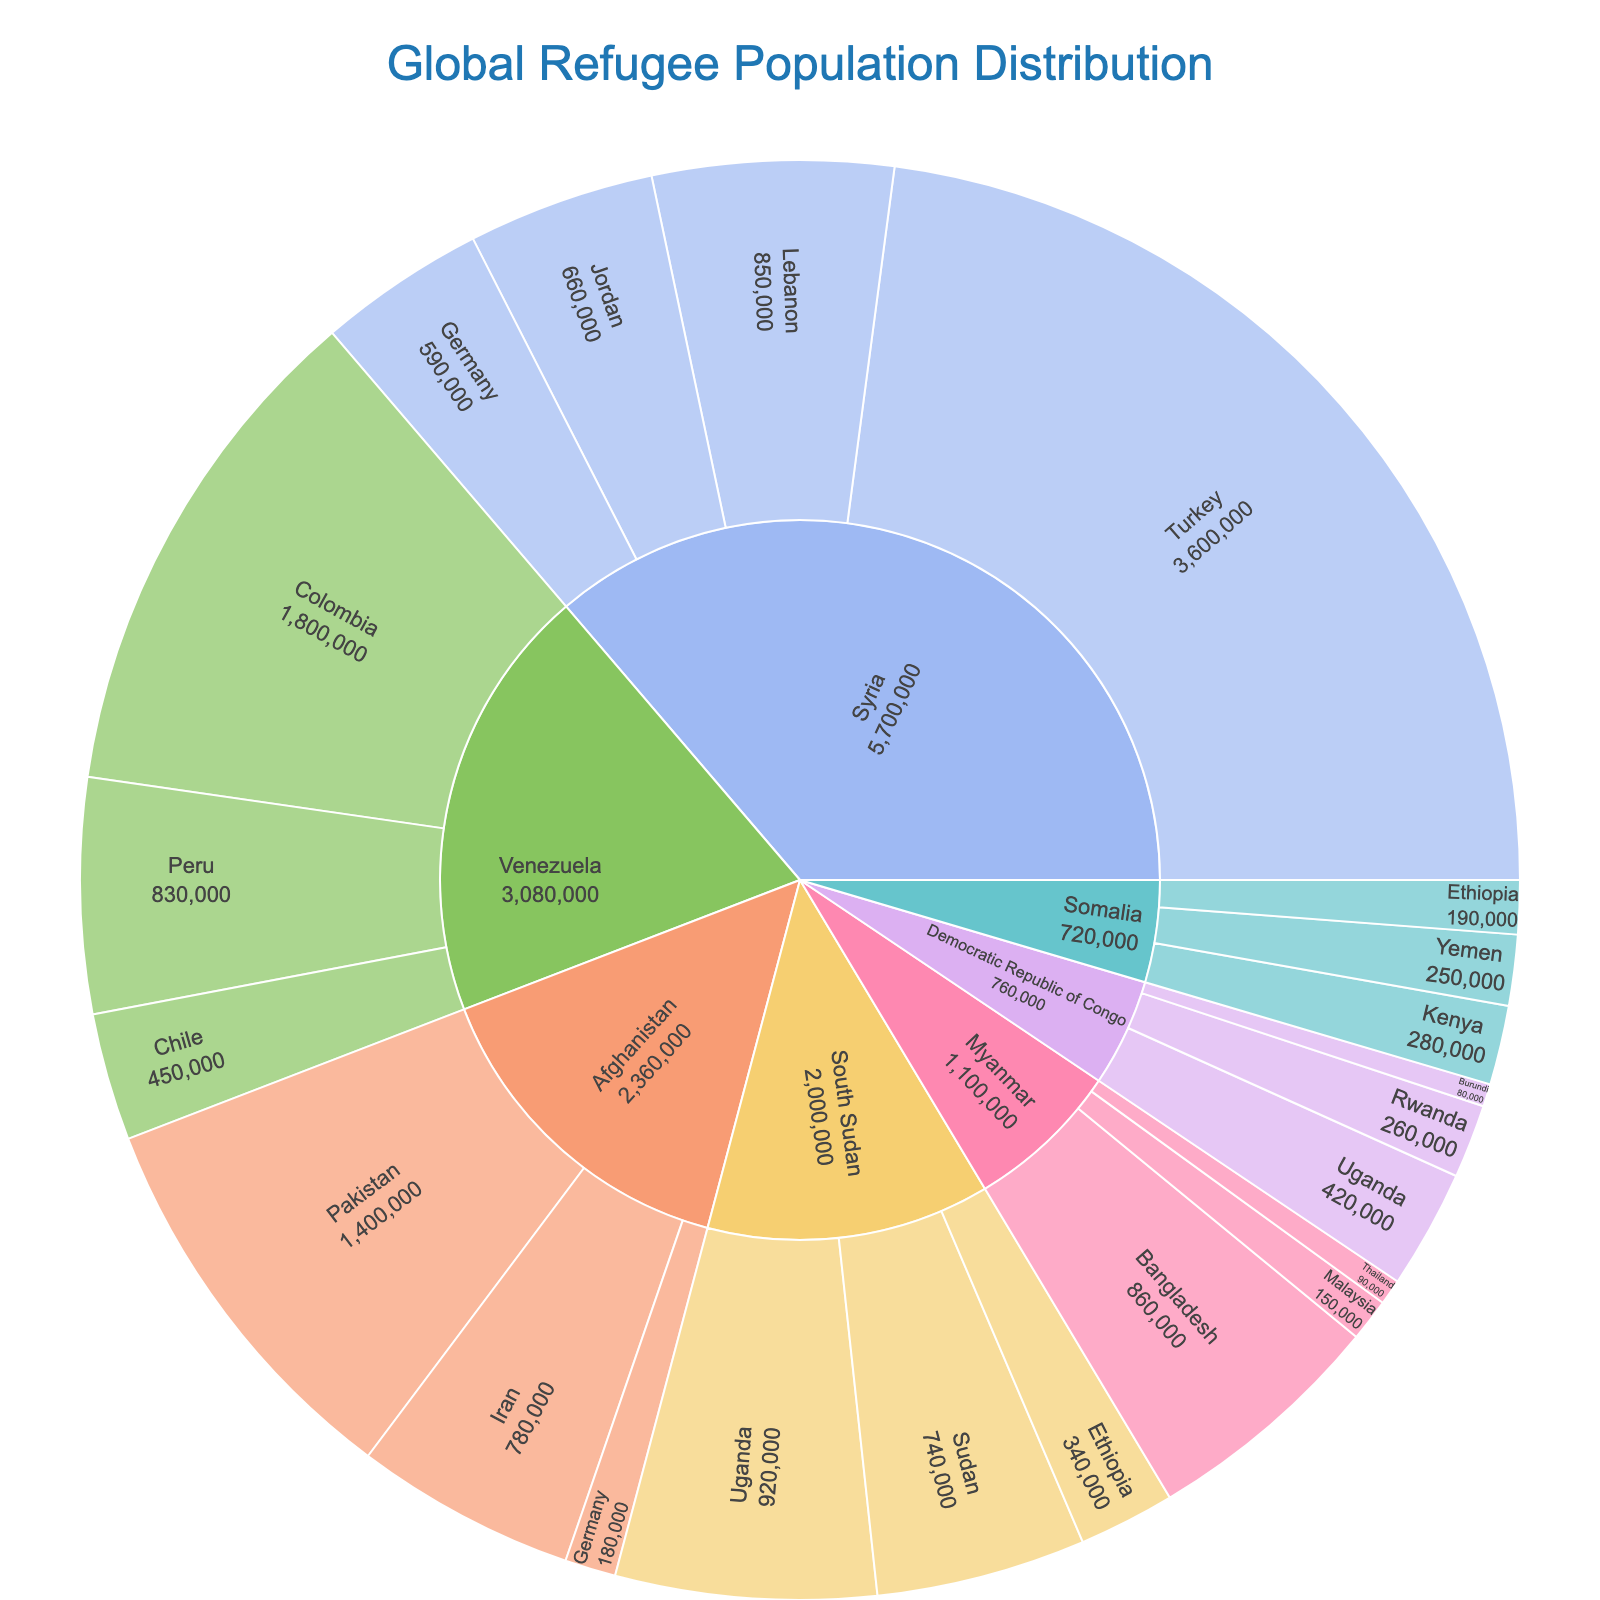what is the title of the plot? The title of the plot is located at the top center of the figure. It is labeled as "Global Refugee Population Distribution".
Answer: Global Refugee Population Distribution Which origin country has the highest number of refugees in Germany? To determine this, identify the section of the Sunburst Plot representing Germany as the host country, then look for the origin countries connected to Germany. Among those, check which one has the largest segment.
Answer: Syria How many total refugees are hosted by Pakistan? To find this, locate the segment of the Sunburst Plot representing Pakistan and sum the population from the different origin countries. In this case, Afghanistan is the only country with its refugees in Pakistan.
Answer: 1,400,000 Compare the number of Syrian refugees hosted by Jordan and Lebanon. Which country hosts more? First, identify the segments representing Syrian refugees in Jordan and in Lebanon in the Sunburst Plot. Then compare the population numbers. Lebanon hosts 850,000, and Jordan hosts 660,000. Lebanon hosts more Syrian refugees.
Answer: Lebanon What's the combined total of Venezuelan refugees in Colombia, Peru, and Chile? Locate the segments representing Venezuelan refugees in Colombia, Peru, and Chile. Sum the population numbers: 1,800,000 (Colombia) + 830,000 (Peru) + 450,000 (Chile). The total is 3,080,000.
Answer: 3,080,000 Which origin country has the smallest refugee population in Rwanda? Locate Rwanda in the plot and then identify the origin countries. Compare the segments to see which one is smallest. The Democratic Republic of Congo is the only country with refugees in Rwanda.
Answer: Democratic Republic of Congo How do the refugee populations from Myanmar in Bangladesh and Thailand compare? Identify the segments for Myanmar refugees in Bangladesh and Thailand. Compare the population numbers. Bangladesh has 860,000 and Thailand has 90,000. Bangladesh hosts more.
Answer: Bangladesh What is the total number of South Sudanese refugees hosted by Sudan and Ethiopia combined? Locate the segments for South Sudanese refugees in Sudan and Ethiopia. Sum the population numbers: 740,000 (Sudan) + 340,000 (Ethiopia). The total is 1,080,000.
Answer: 1,080,000 Which country hosts more refugees from Afghanistan, Germany or Iran? Identify the segments for Afghan refugees in Germany and Iran in the Sunburst Plot. Compare the population numbers. Germany hosts 180,000 and Iran hosts 780,000. Iran hosts more.
Answer: Iran Is the number of Somali refugees in Kenya greater than the number in Yemen? Identify the segments for Somali refugees in Kenya and Yemen. Compare the population numbers. Kenya hosts 280,000 and Yemen hosts 250,000. Yes, it's greater in Kenya.
Answer: Yes 